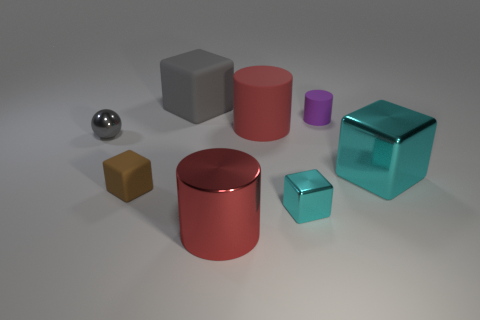How many things are in front of the large rubber block and to the right of the gray metal thing?
Provide a succinct answer. 6. What number of objects are big blue spheres or big red matte cylinders behind the tiny metallic cube?
Provide a succinct answer. 1. What size is the gray block that is made of the same material as the small purple cylinder?
Your answer should be compact. Large. What is the shape of the rubber object in front of the tiny metallic ball that is in front of the gray matte object?
Offer a terse response. Cube. What number of brown objects are either large matte cylinders or tiny shiny spheres?
Ensure brevity in your answer.  0. Are there any small gray things in front of the big cube that is to the right of the red object to the right of the big red shiny cylinder?
Provide a short and direct response. No. What shape is the big rubber object that is the same color as the shiny sphere?
Your response must be concise. Cube. Are there any other things that have the same material as the large gray block?
Your response must be concise. Yes. What number of tiny things are red rubber objects or purple blocks?
Your response must be concise. 0. Is the shape of the tiny rubber object right of the big gray cube the same as  the large red metal object?
Give a very brief answer. Yes. 